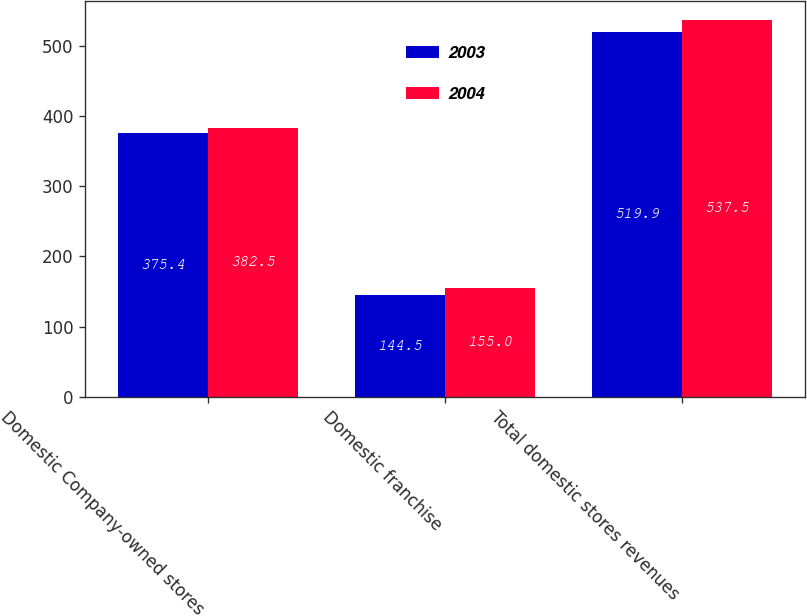<chart> <loc_0><loc_0><loc_500><loc_500><stacked_bar_chart><ecel><fcel>Domestic Company-owned stores<fcel>Domestic franchise<fcel>Total domestic stores revenues<nl><fcel>2003<fcel>375.4<fcel>144.5<fcel>519.9<nl><fcel>2004<fcel>382.5<fcel>155<fcel>537.5<nl></chart> 